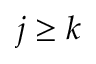<formula> <loc_0><loc_0><loc_500><loc_500>j \geq k</formula> 